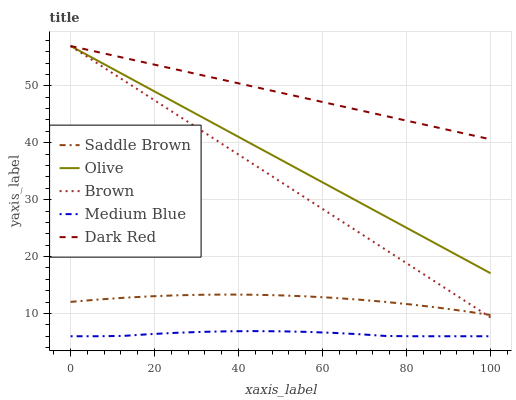Does Medium Blue have the minimum area under the curve?
Answer yes or no. Yes. Does Dark Red have the maximum area under the curve?
Answer yes or no. Yes. Does Brown have the minimum area under the curve?
Answer yes or no. No. Does Brown have the maximum area under the curve?
Answer yes or no. No. Is Dark Red the smoothest?
Answer yes or no. Yes. Is Medium Blue the roughest?
Answer yes or no. Yes. Is Brown the smoothest?
Answer yes or no. No. Is Brown the roughest?
Answer yes or no. No. Does Medium Blue have the lowest value?
Answer yes or no. Yes. Does Brown have the lowest value?
Answer yes or no. No. Does Dark Red have the highest value?
Answer yes or no. Yes. Does Medium Blue have the highest value?
Answer yes or no. No. Is Medium Blue less than Dark Red?
Answer yes or no. Yes. Is Dark Red greater than Saddle Brown?
Answer yes or no. Yes. Does Olive intersect Brown?
Answer yes or no. Yes. Is Olive less than Brown?
Answer yes or no. No. Is Olive greater than Brown?
Answer yes or no. No. Does Medium Blue intersect Dark Red?
Answer yes or no. No. 